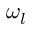<formula> <loc_0><loc_0><loc_500><loc_500>\omega _ { l }</formula> 